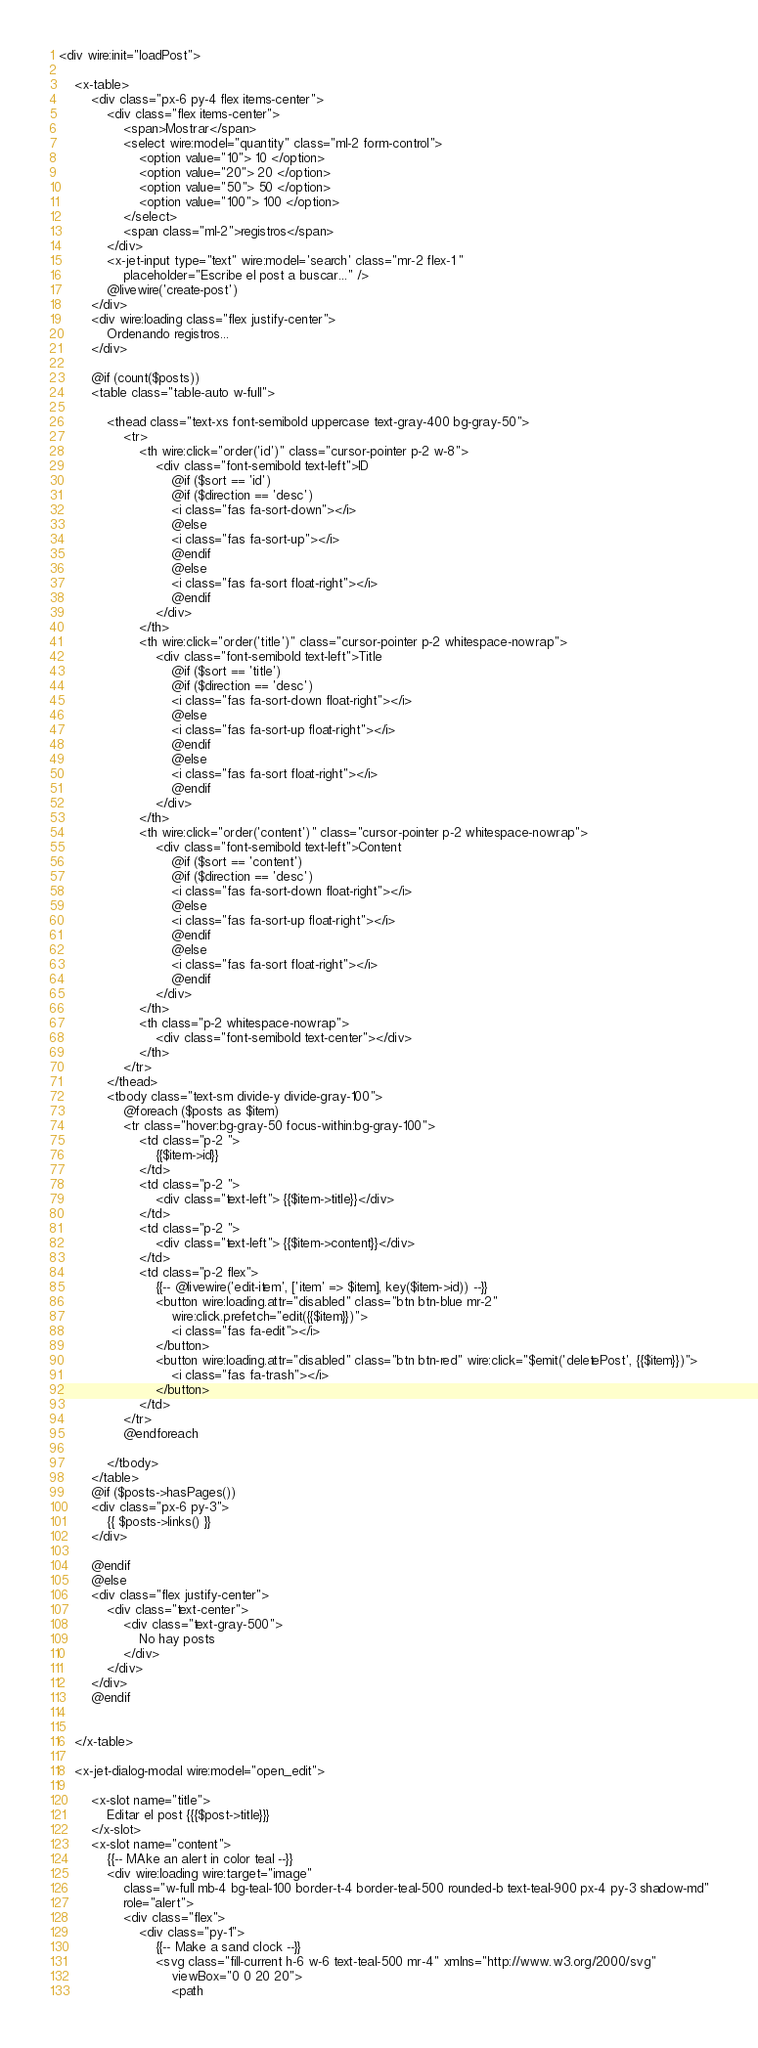<code> <loc_0><loc_0><loc_500><loc_500><_PHP_><div wire:init="loadPost">

    <x-table>
        <div class="px-6 py-4 flex items-center">
            <div class="flex items-center">
                <span>Mostrar</span>
                <select wire:model="quantity" class="ml-2 form-control">
                    <option value="10"> 10 </option>
                    <option value="20"> 20 </option>
                    <option value="50"> 50 </option>
                    <option value="100"> 100 </option>
                </select>
                <span class="ml-2">registros</span>
            </div>
            <x-jet-input type="text" wire:model='search' class="mr-2 flex-1 "
                placeholder="Escribe el post a buscar..." />
            @livewire('create-post')
        </div>
        <div wire:loading class="flex justify-center">
            Ordenando registros...
        </div>

        @if (count($posts))
        <table class="table-auto w-full">

            <thead class="text-xs font-semibold uppercase text-gray-400 bg-gray-50">
                <tr>
                    <th wire:click="order('id')" class="cursor-pointer p-2 w-8">
                        <div class="font-semibold text-left">ID
                            @if ($sort == 'id')
                            @if ($direction == 'desc')
                            <i class="fas fa-sort-down"></i>
                            @else
                            <i class="fas fa-sort-up"></i>
                            @endif
                            @else
                            <i class="fas fa-sort float-right"></i>
                            @endif
                        </div>
                    </th>
                    <th wire:click="order('title')" class="cursor-pointer p-2 whitespace-nowrap">
                        <div class="font-semibold text-left">Title
                            @if ($sort == 'title')
                            @if ($direction == 'desc')
                            <i class="fas fa-sort-down float-right"></i>
                            @else
                            <i class="fas fa-sort-up float-right"></i>
                            @endif
                            @else
                            <i class="fas fa-sort float-right"></i>
                            @endif
                        </div>
                    </th>
                    <th wire:click="order('content')" class="cursor-pointer p-2 whitespace-nowrap">
                        <div class="font-semibold text-left">Content
                            @if ($sort == 'content')
                            @if ($direction == 'desc')
                            <i class="fas fa-sort-down float-right"></i>
                            @else
                            <i class="fas fa-sort-up float-right"></i>
                            @endif
                            @else
                            <i class="fas fa-sort float-right"></i>
                            @endif
                        </div>
                    </th>
                    <th class="p-2 whitespace-nowrap">
                        <div class="font-semibold text-center"></div>
                    </th>
                </tr>
            </thead>
            <tbody class="text-sm divide-y divide-gray-100">
                @foreach ($posts as $item)
                <tr class="hover:bg-gray-50 focus-within:bg-gray-100">
                    <td class="p-2 ">
                        {{$item->id}}
                    </td>
                    <td class="p-2 ">
                        <div class="text-left"> {{$item->title}}</div>
                    </td>
                    <td class="p-2 ">
                        <div class="text-left"> {{$item->content}}</div>
                    </td>
                    <td class="p-2 flex">
                        {{-- @livewire('edit-item', ['item' => $item], key($item->id)) --}}
                        <button wire:loading.attr="disabled" class="btn btn-blue mr-2"
                            wire:click.prefetch="edit({{$item}})">
                            <i class="fas fa-edit"></i>
                        </button>
                        <button wire:loading.attr="disabled" class="btn btn-red" wire:click="$emit('deletePost', {{$item}})">
                            <i class="fas fa-trash"></i>
                        </button>
                    </td>
                </tr>
                @endforeach

            </tbody>
        </table>
        @if ($posts->hasPages())
        <div class="px-6 py-3">
            {{ $posts->links() }}
        </div>

        @endif
        @else
        <div class="flex justify-center">
            <div class="text-center">
                <div class="text-gray-500">
                    No hay posts
                </div>
            </div>
        </div>
        @endif


    </x-table>

    <x-jet-dialog-modal wire:model="open_edit">

        <x-slot name="title">
            Editar el post {{{$post->title}}}
        </x-slot>
        <x-slot name="content">
            {{-- MAke an alert in color teal --}}
            <div wire:loading wire:target="image"
                class="w-full mb-4 bg-teal-100 border-t-4 border-teal-500 rounded-b text-teal-900 px-4 py-3 shadow-md"
                role="alert">
                <div class="flex">
                    <div class="py-1">
                        {{-- Make a sand clock --}}
                        <svg class="fill-current h-6 w-6 text-teal-500 mr-4" xmlns="http://www.w3.org/2000/svg"
                            viewBox="0 0 20 20">
                            <path</code> 